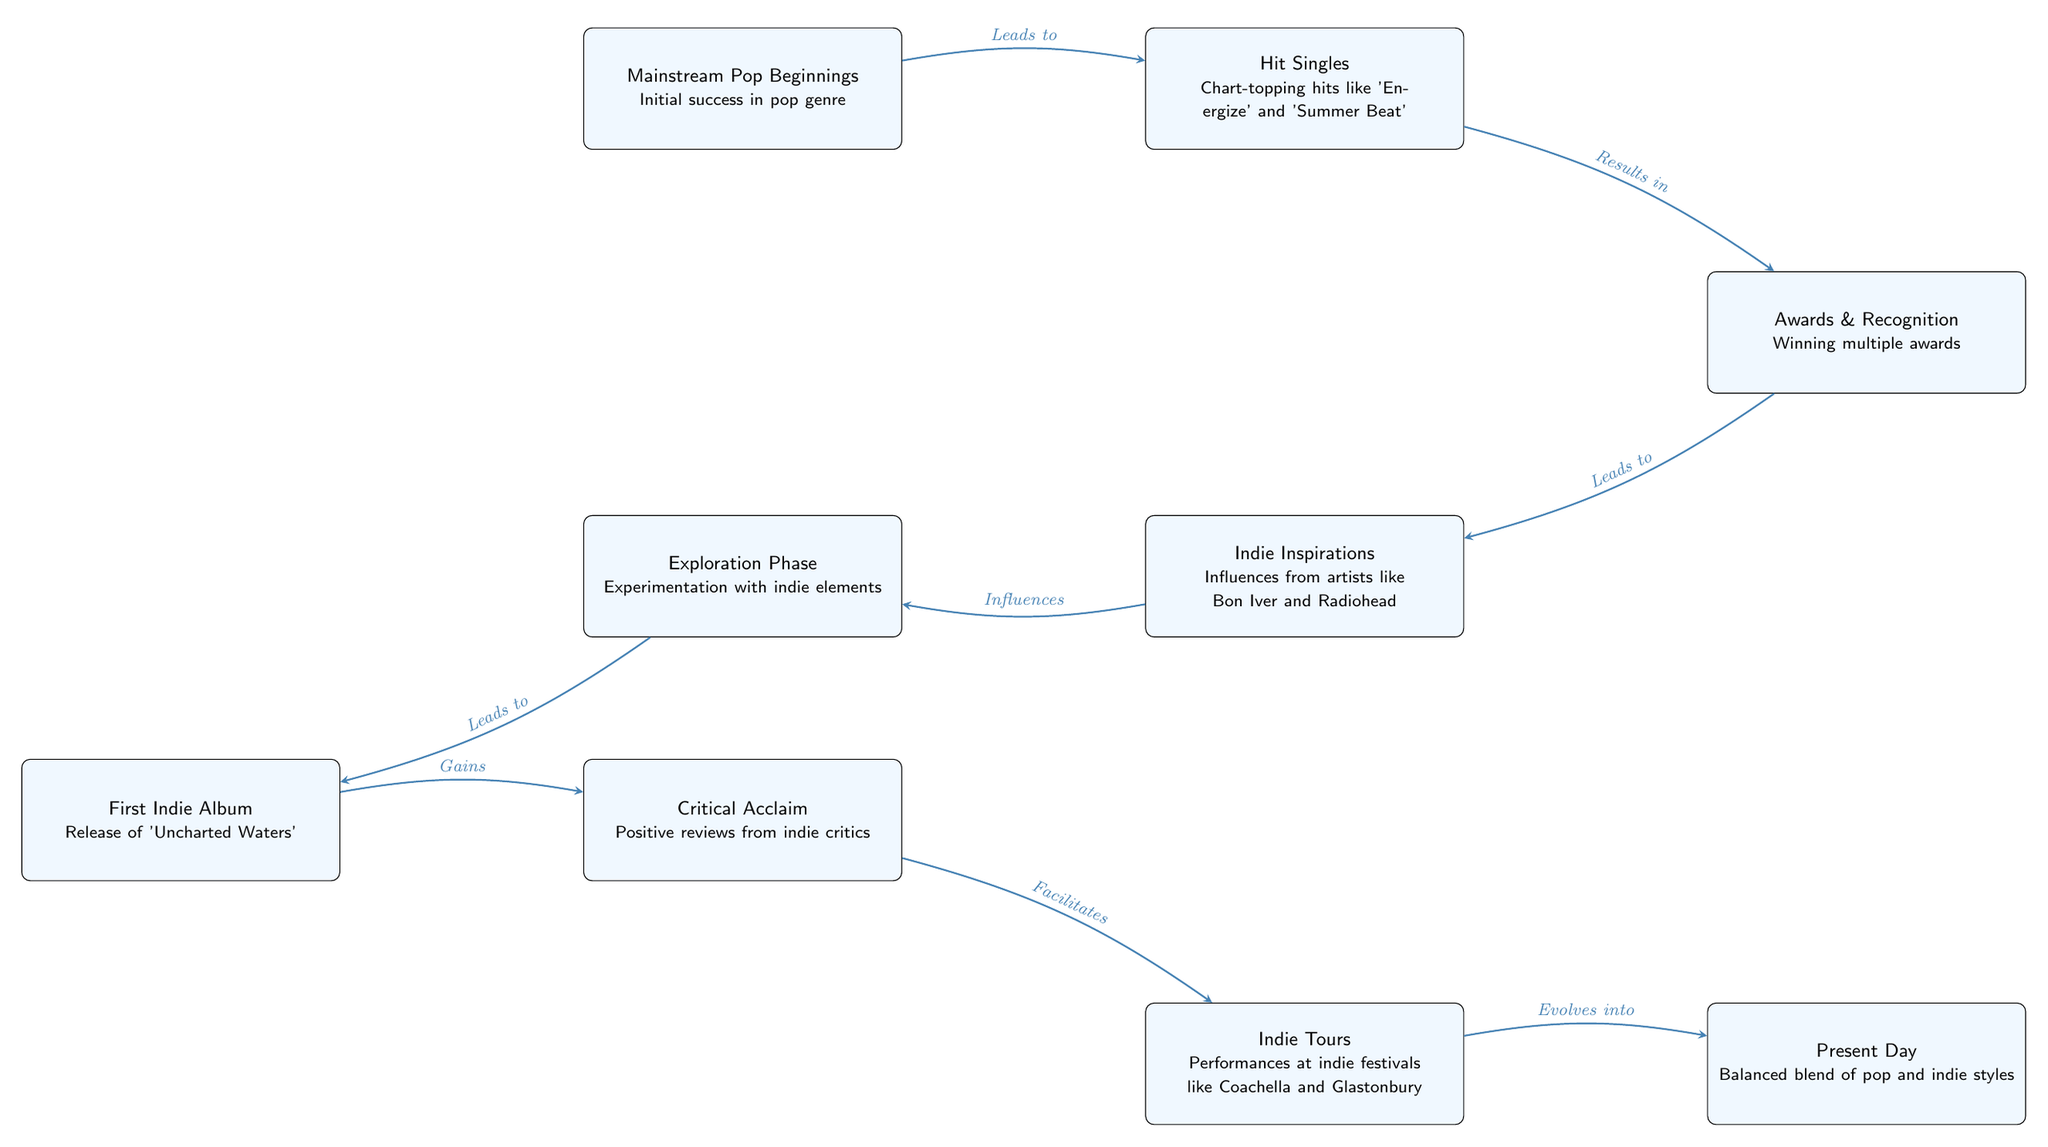What node represents the beginning of your music journey? The node located at the top left of the diagram labeled "Mainstream Pop Beginnings" signifies the start of the music journey, detailing initial success in the pop genre.
Answer: Mainstream Pop Beginnings How many key influences are shown in the diagram? The diagram includes one specific node labeled "Indie Inspirations," which denotes influences from artists like Bon Iver and Radiohead, indicating a single key influence node.
Answer: 1 What milestone follows the exploration phase? In the diagram, following "Exploration Phase" is the node labeled "First Indie Album," which represents a significant achievement after experimenting with indie elements.
Answer: First Indie Album Which node indicates the current state of your music style? The last node in the diagram, labeled "Present Day," illustrates the current state of the music style as a balanced blend of pop and indie styles.
Answer: Present Day What leads to the critical acclaim of your first indie album? The node "First Indie Album" has an arrow leading to "Critical Acclaim," indicating that the release of the album resulted in positive reviews from indie critics.
Answer: Gains How many edges connect the nodes in the diagram? By counting every arrow connecting the nodes, there are a total of 7 edges connecting all the key milestones and influences in the diagram.
Answer: 7 Which artists influenced your transition into indie music? The node labeled "Indie Inspirations" specifically mentions influences from Bon Iver and Radiohead, which are the artists that inspired the move towards indie music.
Answer: Bon Iver and Radiohead What does "Facilitates" refer to in the diagram? The word "Facilitates" indicates that the node "Critical Acclaim" enables or supports the following node "Indie Tours," suggesting a progression from acclaim to live performances.
Answer: Indie Tours 